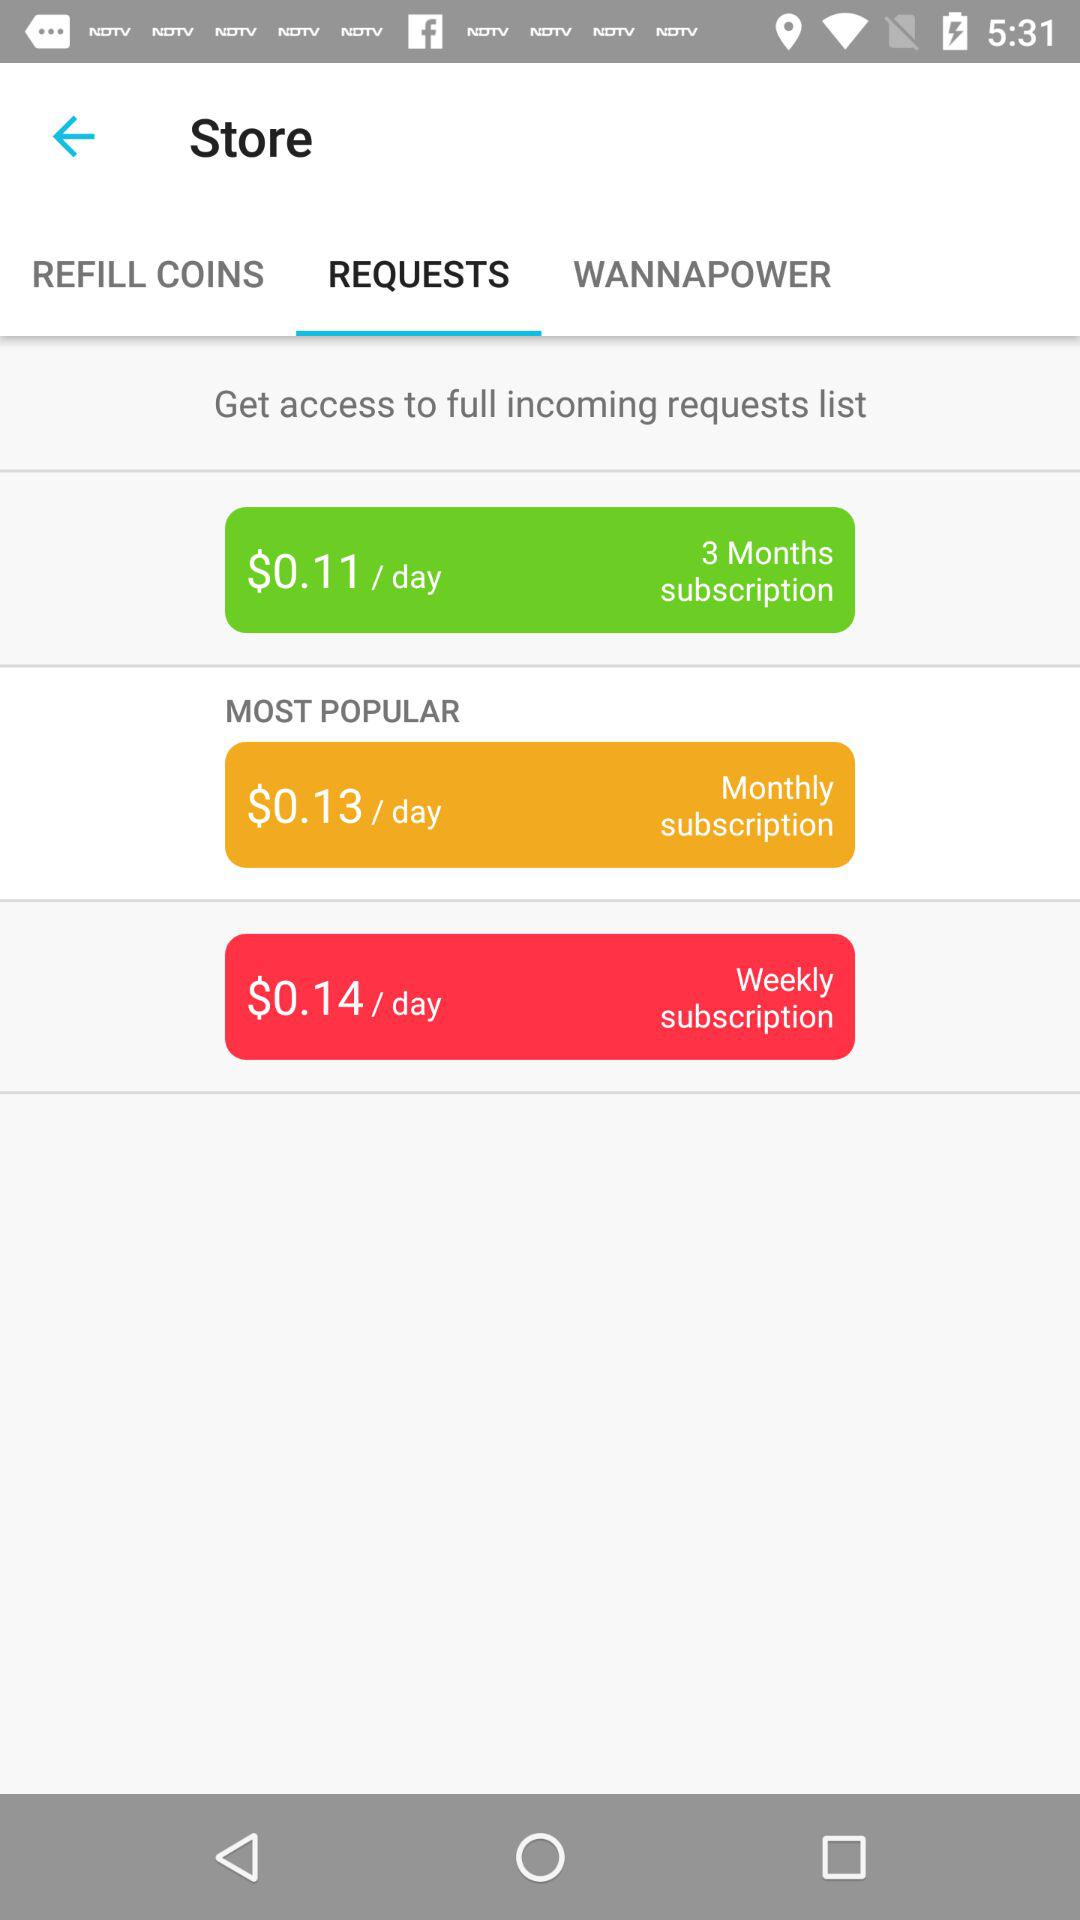Which tab is selected? The selected tab is "REQUESTS". 